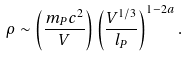Convert formula to latex. <formula><loc_0><loc_0><loc_500><loc_500>\rho \sim \left ( \frac { m _ { P } c ^ { 2 } } { V } \right ) \left ( \frac { V ^ { 1 / 3 } } { l _ { P } } \right ) ^ { 1 - 2 a } .</formula> 